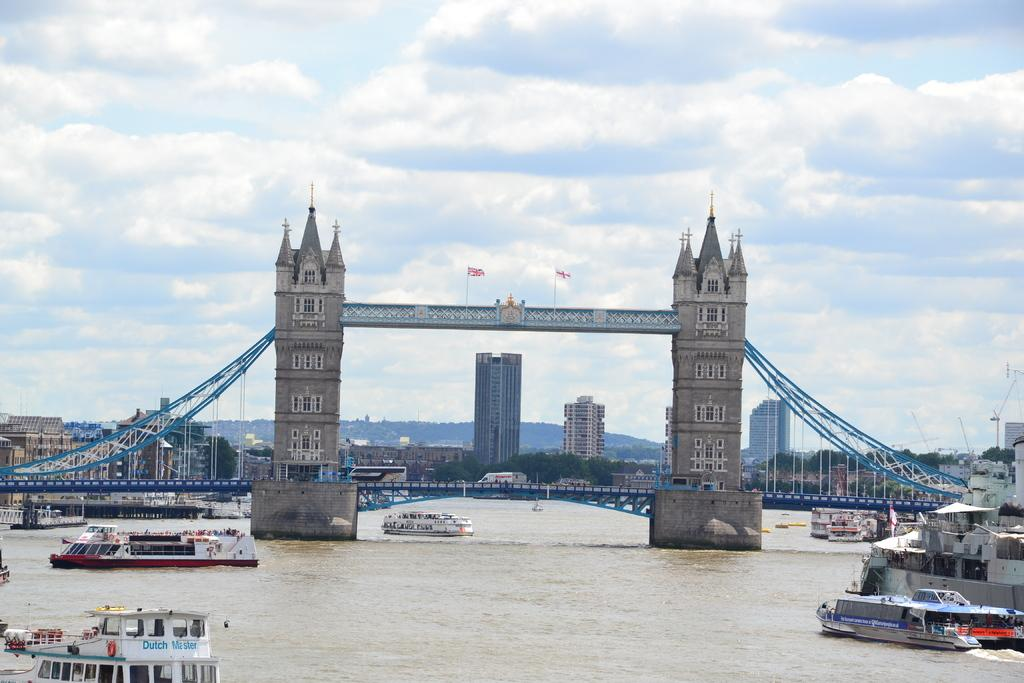What can be seen on the water in the image? There are ships on the water in the image. What type of bridge is present in the image? There is a tower bridge in the image. What is visible behind the tower bridge? Trees and buildings are visible behind the tower bridge. How would you describe the sky in the image? The sky is cloudy in the image. What type of pan is hanging from the tower bridge in the image? There is no pan present in the image; the tower bridge is a type of bridge and does not have any pans hanging from it. 